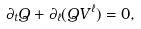<formula> <loc_0><loc_0><loc_500><loc_500>\partial _ { t } Q + \partial _ { \ell } ( Q V ^ { \ell } ) = 0 ,</formula> 